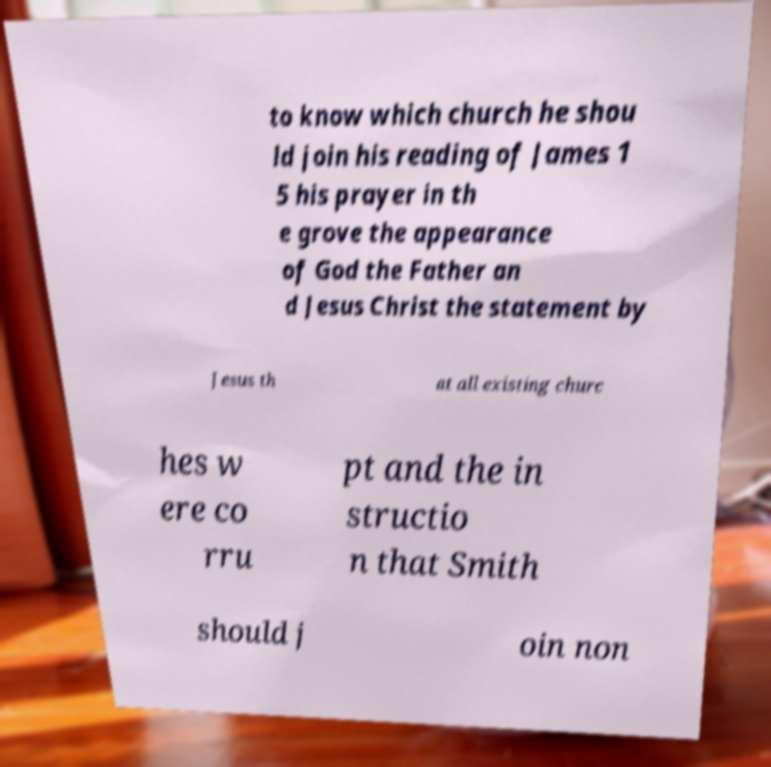Could you extract and type out the text from this image? to know which church he shou ld join his reading of James 1 5 his prayer in th e grove the appearance of God the Father an d Jesus Christ the statement by Jesus th at all existing churc hes w ere co rru pt and the in structio n that Smith should j oin non 